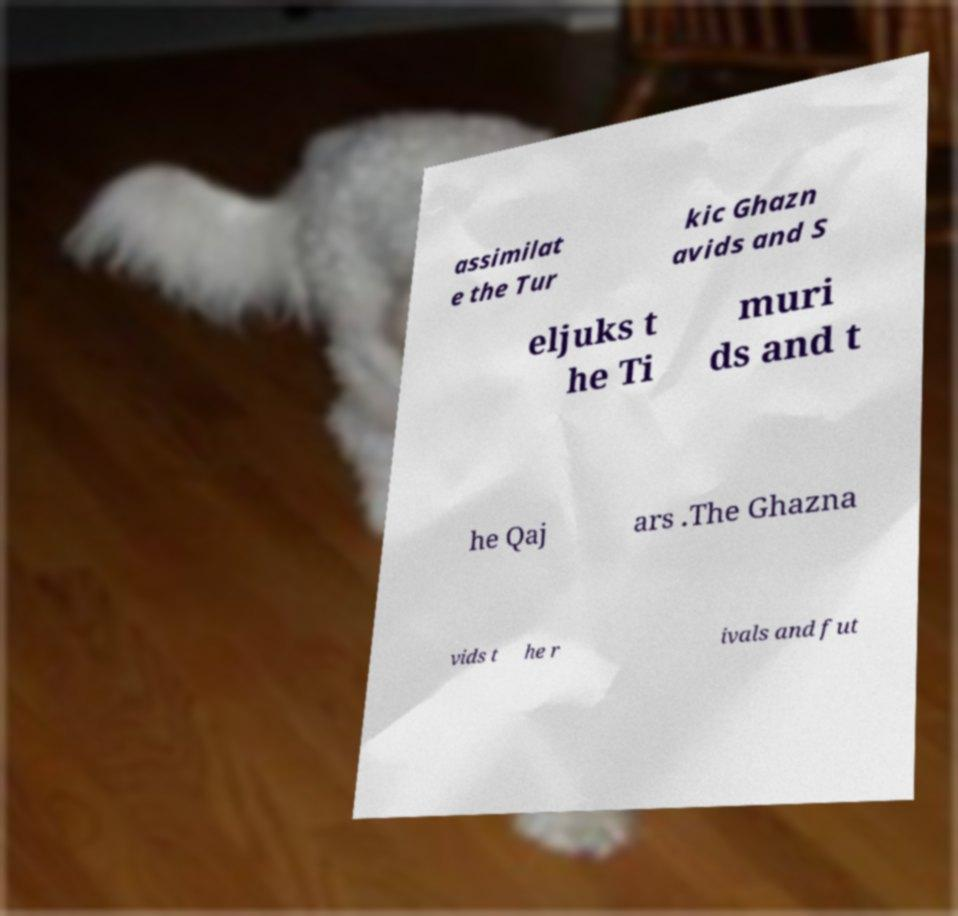Please identify and transcribe the text found in this image. assimilat e the Tur kic Ghazn avids and S eljuks t he Ti muri ds and t he Qaj ars .The Ghazna vids t he r ivals and fut 